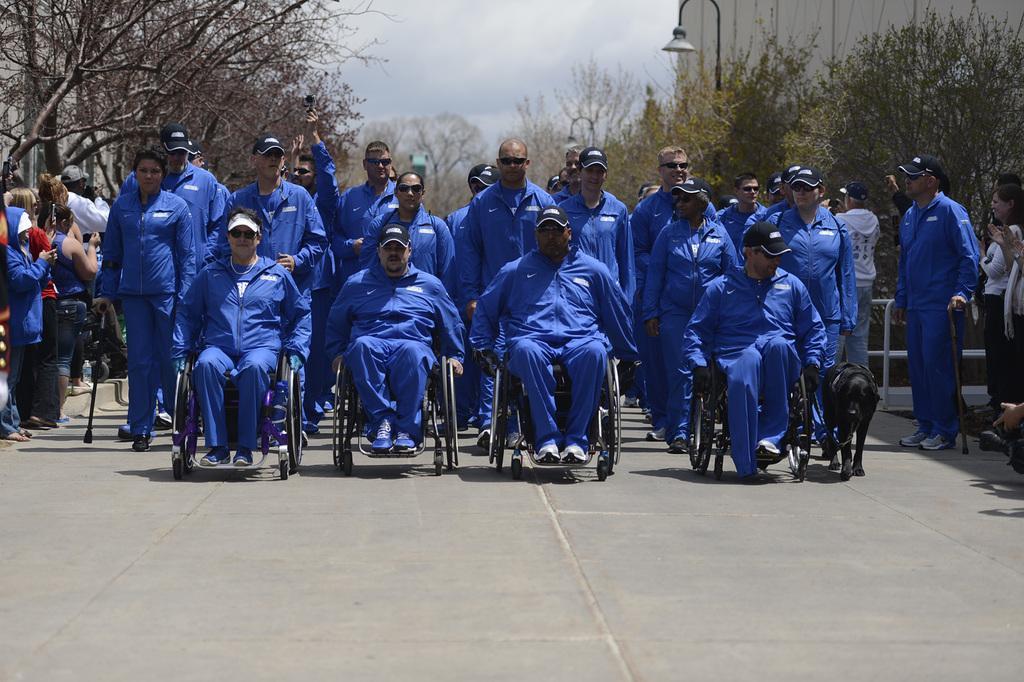Could you give a brief overview of what you see in this image? In this image in the center there are some people who are standing and some of them are sitting on a wheelchair, and on the right side and left side there are some people who are standing and there is one dog. In the background there are some trees and houses, at the bottom there is a walkway. 